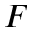<formula> <loc_0><loc_0><loc_500><loc_500>F</formula> 